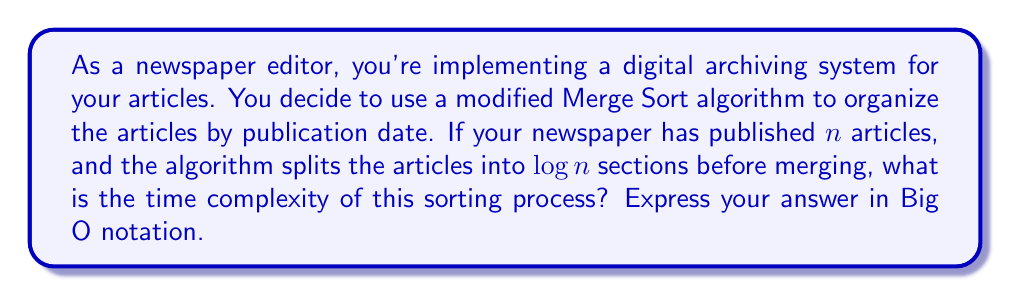Provide a solution to this math problem. Let's analyze this step-by-step:

1) In a standard Merge Sort, the algorithm divides the input into two halves recursively until we have individual elements. In this case, we're dividing into $\log n$ sections instead.

2) The division process takes $O(\log n)$ time, as we're making $\log n$ divisions.

3) After division, we need to merge these $\log n$ sections. In a standard Merge Sort, merging takes $O(n)$ time for each level of recursion.

4) Here, we have only one level of merging (as we divided into $\log n$ sections at once), but we need to merge $\log n$ sections instead of just 2.

5) Merging $\log n$ sorted lists can be done using a min-heap. Building the initial heap takes $O(\log n)$ time.

6) For each of the $n$ elements, we perform an extract-min operation (which takes $O(\log \log n)$ time) and an insert operation (also $O(\log \log n)$ time).

7) Therefore, the merging process takes $O(n \log \log n)$ time.

8) The total time complexity is the sum of the division and merging times:

   $T(n) = O(\log n) + O(n \log \log n)$

9) As $n$ grows large, the $O(n \log \log n)$ term dominates the $O(\log n)$ term.

Therefore, the overall time complexity of this modified Merge Sort is $O(n \log \log n)$.
Answer: $O(n \log \log n)$ 